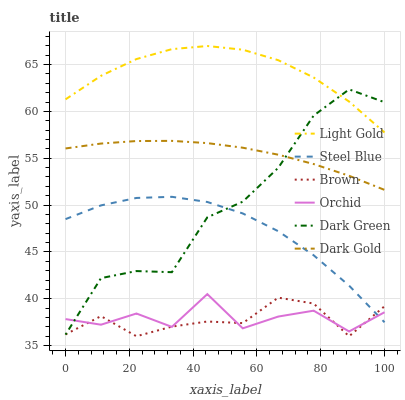Does Brown have the minimum area under the curve?
Answer yes or no. Yes. Does Light Gold have the maximum area under the curve?
Answer yes or no. Yes. Does Dark Gold have the minimum area under the curve?
Answer yes or no. No. Does Dark Gold have the maximum area under the curve?
Answer yes or no. No. Is Dark Gold the smoothest?
Answer yes or no. Yes. Is Orchid the roughest?
Answer yes or no. Yes. Is Steel Blue the smoothest?
Answer yes or no. No. Is Steel Blue the roughest?
Answer yes or no. No. Does Brown have the lowest value?
Answer yes or no. Yes. Does Dark Gold have the lowest value?
Answer yes or no. No. Does Light Gold have the highest value?
Answer yes or no. Yes. Does Dark Gold have the highest value?
Answer yes or no. No. Is Brown less than Dark Gold?
Answer yes or no. Yes. Is Dark Gold greater than Orchid?
Answer yes or no. Yes. Does Light Gold intersect Dark Green?
Answer yes or no. Yes. Is Light Gold less than Dark Green?
Answer yes or no. No. Is Light Gold greater than Dark Green?
Answer yes or no. No. Does Brown intersect Dark Gold?
Answer yes or no. No. 